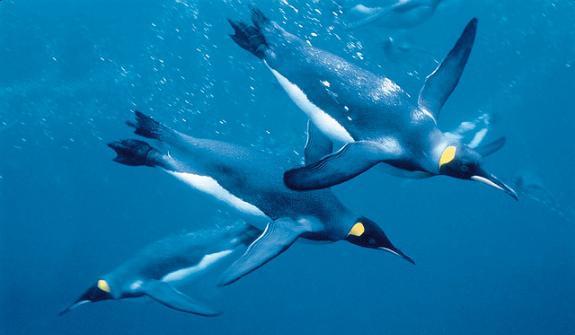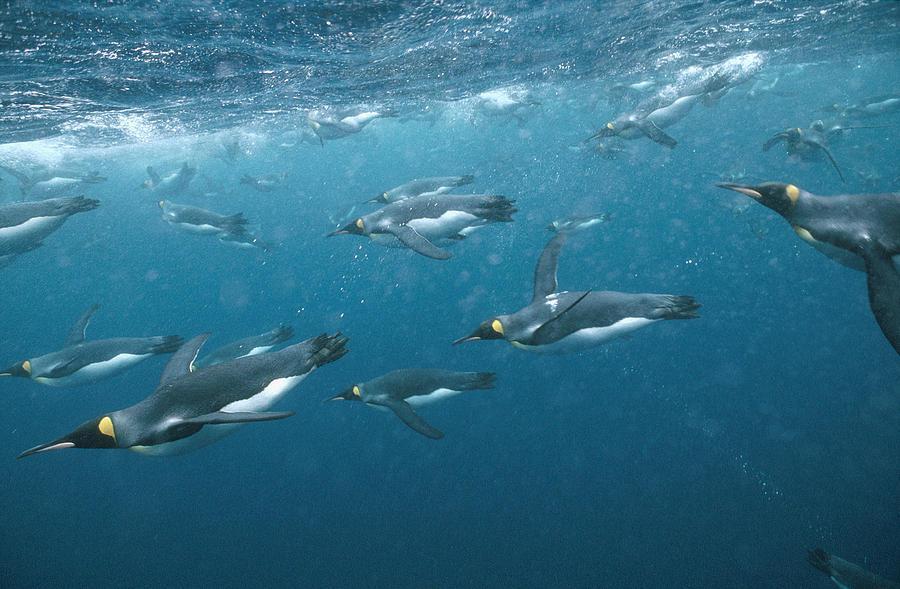The first image is the image on the left, the second image is the image on the right. Examine the images to the left and right. Is the description "An image shows exactly one penguin, which is swimming leftward in front of rocky structures." accurate? Answer yes or no. No. 